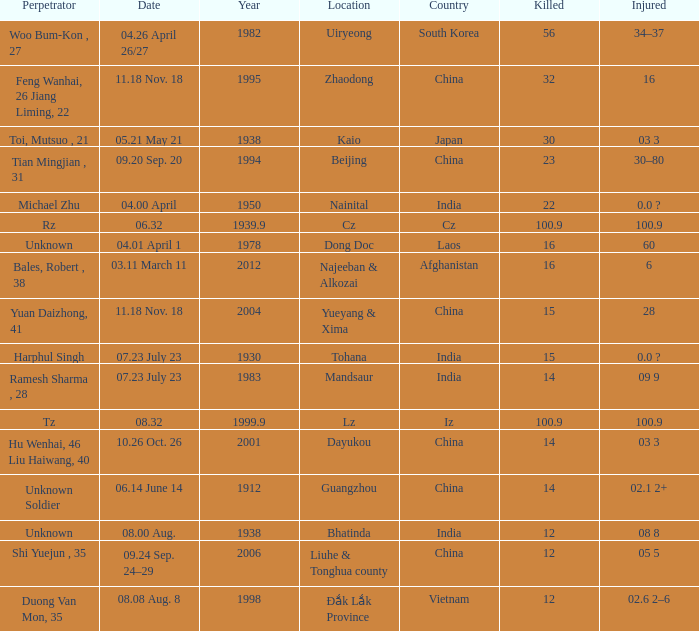What is Injured, when Country is "Afghanistan"? 6.0. 